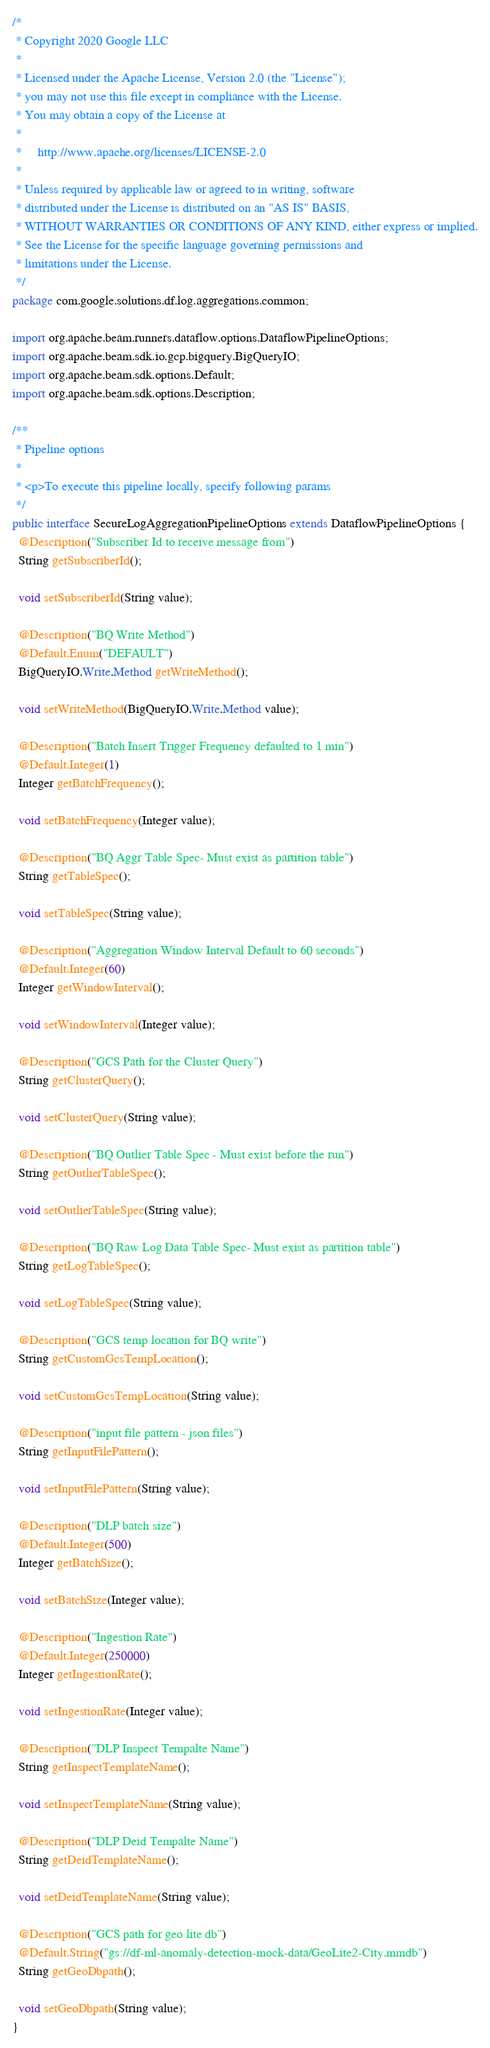Convert code to text. <code><loc_0><loc_0><loc_500><loc_500><_Java_>/*
 * Copyright 2020 Google LLC
 *
 * Licensed under the Apache License, Version 2.0 (the "License");
 * you may not use this file except in compliance with the License.
 * You may obtain a copy of the License at
 *
 *     http://www.apache.org/licenses/LICENSE-2.0
 *
 * Unless required by applicable law or agreed to in writing, software
 * distributed under the License is distributed on an "AS IS" BASIS,
 * WITHOUT WARRANTIES OR CONDITIONS OF ANY KIND, either express or implied.
 * See the License for the specific language governing permissions and
 * limitations under the License.
 */
package com.google.solutions.df.log.aggregations.common;

import org.apache.beam.runners.dataflow.options.DataflowPipelineOptions;
import org.apache.beam.sdk.io.gcp.bigquery.BigQueryIO;
import org.apache.beam.sdk.options.Default;
import org.apache.beam.sdk.options.Description;

/**
 * Pipeline options
 *
 * <p>To execute this pipeline locally, specify following params
 */
public interface SecureLogAggregationPipelineOptions extends DataflowPipelineOptions {
  @Description("Subscriber Id to receive message from")
  String getSubscriberId();

  void setSubscriberId(String value);

  @Description("BQ Write Method")
  @Default.Enum("DEFAULT")
  BigQueryIO.Write.Method getWriteMethod();

  void setWriteMethod(BigQueryIO.Write.Method value);

  @Description("Batch Insert Trigger Frequency defaulted to 1 min")
  @Default.Integer(1)
  Integer getBatchFrequency();

  void setBatchFrequency(Integer value);

  @Description("BQ Aggr Table Spec- Must exist as partition table")
  String getTableSpec();

  void setTableSpec(String value);

  @Description("Aggregation Window Interval Default to 60 seconds")
  @Default.Integer(60)
  Integer getWindowInterval();

  void setWindowInterval(Integer value);

  @Description("GCS Path for the Cluster Query")
  String getClusterQuery();

  void setClusterQuery(String value);

  @Description("BQ Outlier Table Spec - Must exist before the run")
  String getOutlierTableSpec();

  void setOutlierTableSpec(String value);

  @Description("BQ Raw Log Data Table Spec- Must exist as partition table")
  String getLogTableSpec();

  void setLogTableSpec(String value);

  @Description("GCS temp location for BQ write")
  String getCustomGcsTempLocation();

  void setCustomGcsTempLocation(String value);

  @Description("input file pattern - json files")
  String getInputFilePattern();

  void setInputFilePattern(String value);

  @Description("DLP batch size")
  @Default.Integer(500)
  Integer getBatchSize();

  void setBatchSize(Integer value);

  @Description("Ingestion Rate")
  @Default.Integer(250000)
  Integer getIngestionRate();

  void setIngestionRate(Integer value);

  @Description("DLP Inspect Tempalte Name")
  String getInspectTemplateName();

  void setInspectTemplateName(String value);

  @Description("DLP Deid Tempalte Name")
  String getDeidTemplateName();

  void setDeidTemplateName(String value);

  @Description("GCS path for geo lite db")
  @Default.String("gs://df-ml-anomaly-detection-mock-data/GeoLite2-City.mmdb")
  String getGeoDbpath();

  void setGeoDbpath(String value);
}
</code> 